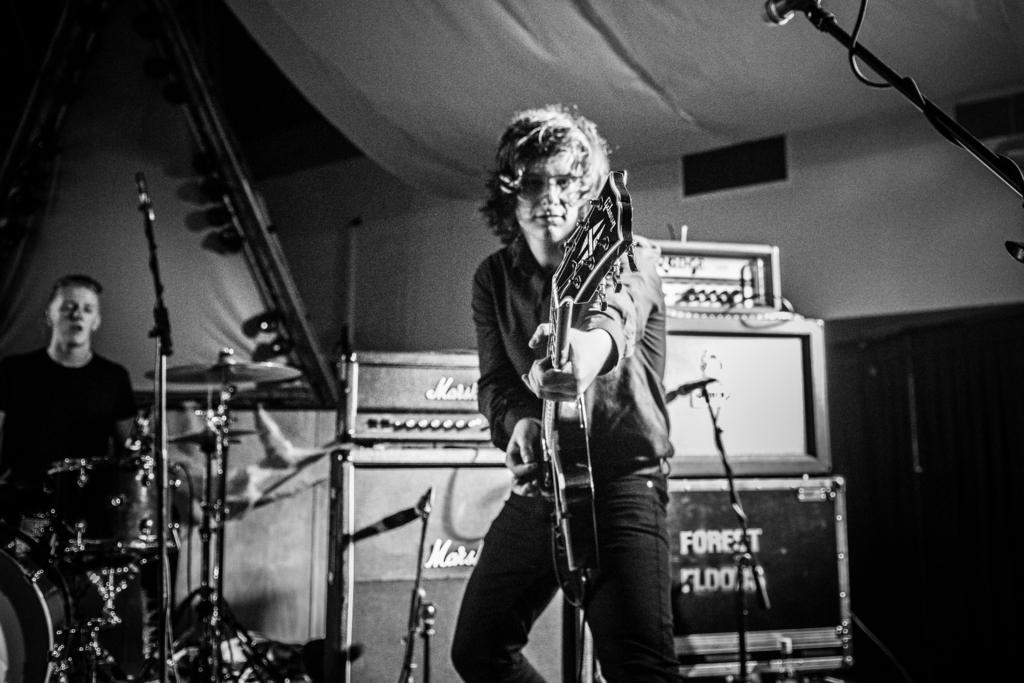Could you give a brief overview of what you see in this image? This is a black and white picture. There are two persons standing on a stage and holding music instrument in front of these people there are microphone with stand. Behind the people there are some music systems and boxes and a tent. 